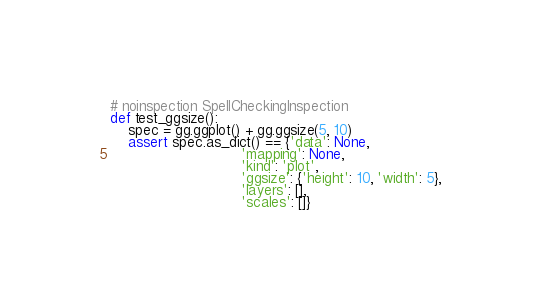Convert code to text. <code><loc_0><loc_0><loc_500><loc_500><_Python_>
# noinspection SpellCheckingInspection
def test_ggsize():
    spec = gg.ggplot() + gg.ggsize(5, 10)
    assert spec.as_dict() == {'data': None,
                              'mapping': None,
                              'kind': 'plot',
                              'ggsize': {'height': 10, 'width': 5},
                              'layers': [],
                              'scales': []}
</code> 